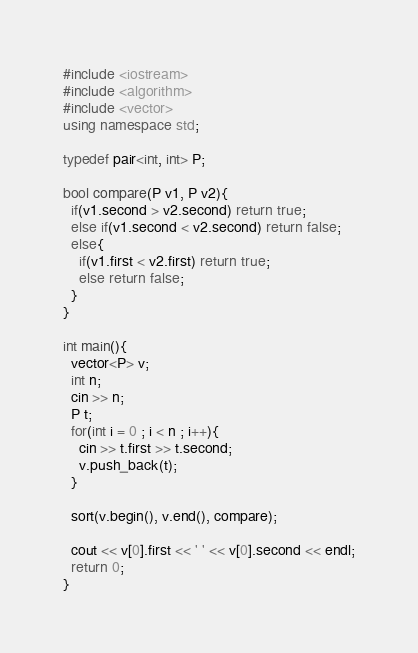Convert code to text. <code><loc_0><loc_0><loc_500><loc_500><_C++_>#include <iostream>
#include <algorithm>
#include <vector>
using namespace std;

typedef pair<int, int> P;

bool compare(P v1, P v2){
  if(v1.second > v2.second) return true;
  else if(v1.second < v2.second) return false;
  else{
    if(v1.first < v2.first) return true;
    else return false;
  }
}
  
int main(){
  vector<P> v;
  int n;
  cin >> n;
  P t;
  for(int i = 0 ; i < n ; i++){
    cin >> t.first >> t.second;
    v.push_back(t);
  }

  sort(v.begin(), v.end(), compare);
  
  cout << v[0].first << ' ' << v[0].second << endl;
  return 0;
}</code> 